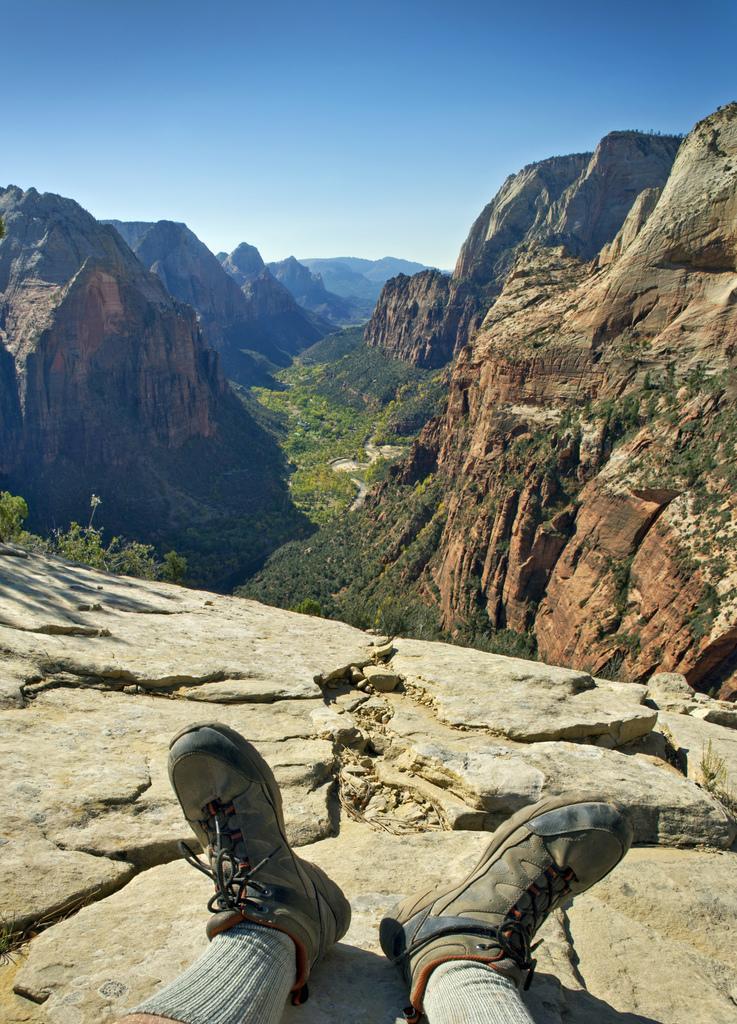How would you summarize this image in a sentence or two? There is a person wearing shoes and shocks on the surface of a hill. In the background, there are mountains and there is blue sky. 